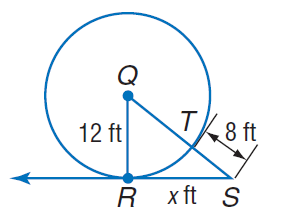Question: Find x. Assume that segments that appear to be tangent are tangent.
Choices:
A. 8
B. 12
C. 16
D. 20
Answer with the letter. Answer: C 